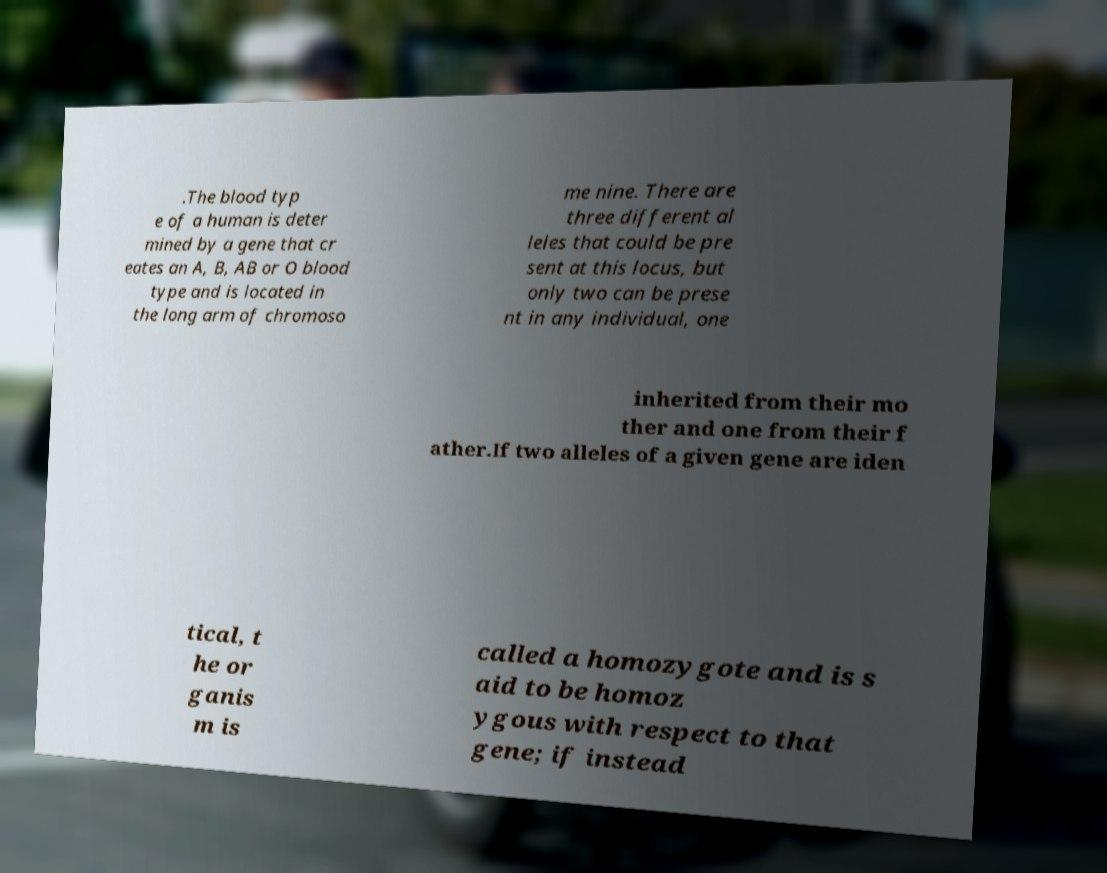For documentation purposes, I need the text within this image transcribed. Could you provide that? .The blood typ e of a human is deter mined by a gene that cr eates an A, B, AB or O blood type and is located in the long arm of chromoso me nine. There are three different al leles that could be pre sent at this locus, but only two can be prese nt in any individual, one inherited from their mo ther and one from their f ather.If two alleles of a given gene are iden tical, t he or ganis m is called a homozygote and is s aid to be homoz ygous with respect to that gene; if instead 